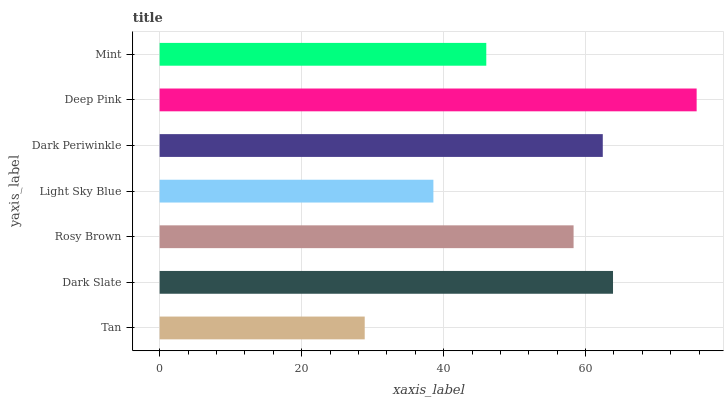Is Tan the minimum?
Answer yes or no. Yes. Is Deep Pink the maximum?
Answer yes or no. Yes. Is Dark Slate the minimum?
Answer yes or no. No. Is Dark Slate the maximum?
Answer yes or no. No. Is Dark Slate greater than Tan?
Answer yes or no. Yes. Is Tan less than Dark Slate?
Answer yes or no. Yes. Is Tan greater than Dark Slate?
Answer yes or no. No. Is Dark Slate less than Tan?
Answer yes or no. No. Is Rosy Brown the high median?
Answer yes or no. Yes. Is Rosy Brown the low median?
Answer yes or no. Yes. Is Deep Pink the high median?
Answer yes or no. No. Is Light Sky Blue the low median?
Answer yes or no. No. 